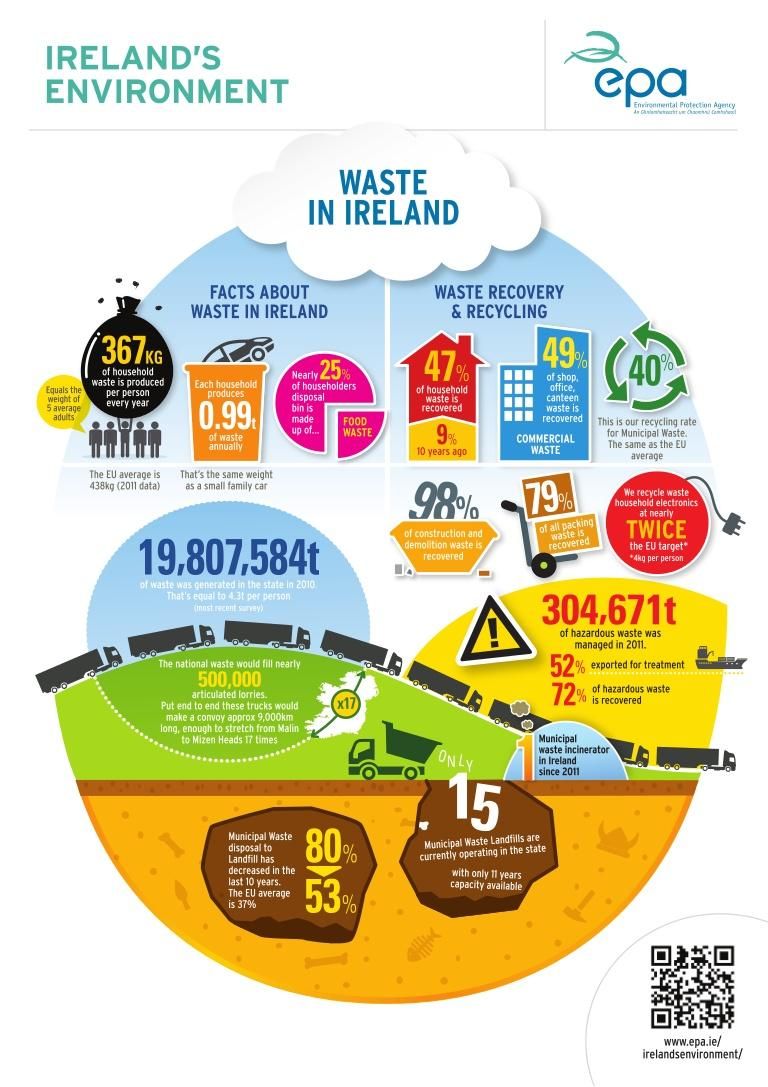Outline some significant characteristics in this image. More than 25% of household waste is made up of food waste. Currently, 53% of municipal waste is disposed of in landfills. Packing waste has been recovered at a rate of 79%. According to recent data, the current recovery rate of household waste is 47%. Ten years ago, the recovery rate of household waste was just 9%. This indicates that there is room for improvement in waste management practices to ensure a more sustainable future. 